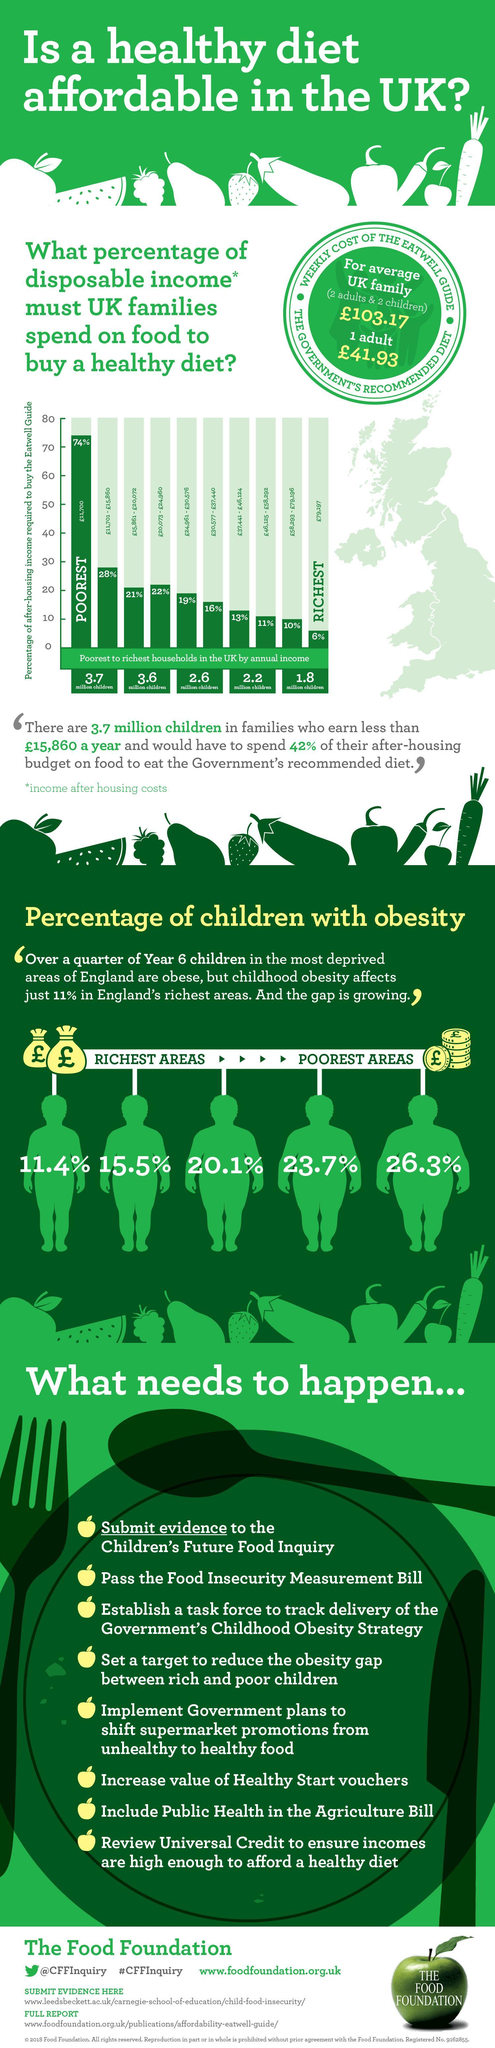What is the percent of obesity in England's poorest areas?
Answer the question with a short phrase. 26.3% What percent of income has to be spent by the poorest people to buy a healthy diet? 74% What percent of income has to be spent by the richest people to buy a healthy diet? 6% 